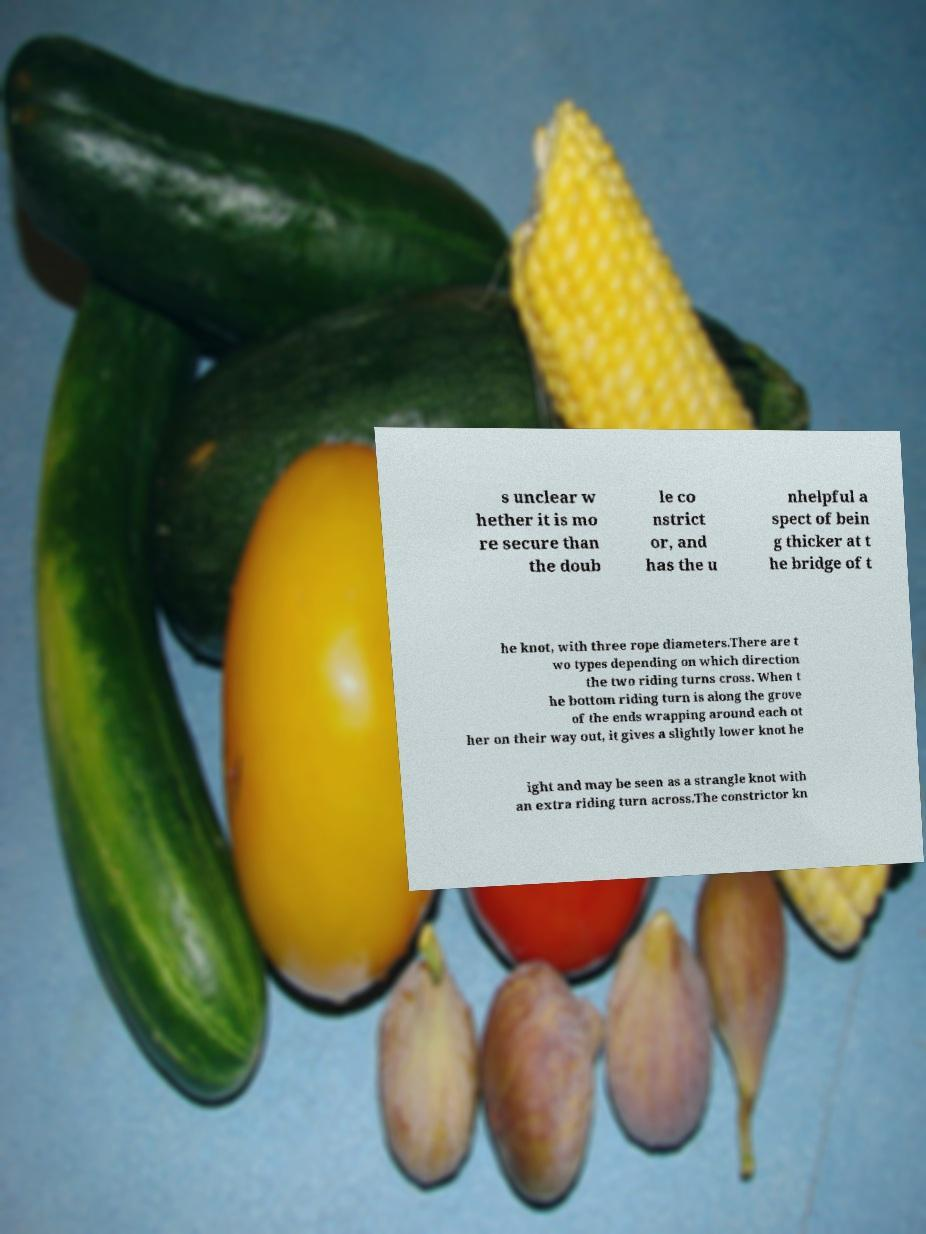There's text embedded in this image that I need extracted. Can you transcribe it verbatim? s unclear w hether it is mo re secure than the doub le co nstrict or, and has the u nhelpful a spect of bein g thicker at t he bridge of t he knot, with three rope diameters.There are t wo types depending on which direction the two riding turns cross. When t he bottom riding turn is along the grove of the ends wrapping around each ot her on their way out, it gives a slightly lower knot he ight and may be seen as a strangle knot with an extra riding turn across.The constrictor kn 